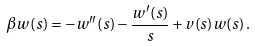Convert formula to latex. <formula><loc_0><loc_0><loc_500><loc_500>\beta w ( s ) = - w ^ { \prime \prime } ( s ) - \frac { w ^ { \prime } ( s ) } { s } + v ( s ) w ( s ) \, .</formula> 